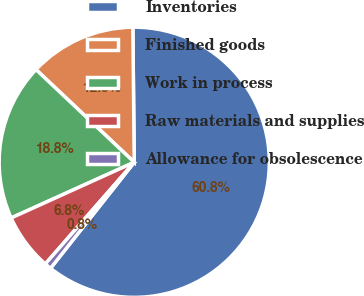Convert chart. <chart><loc_0><loc_0><loc_500><loc_500><pie_chart><fcel>Inventories<fcel>Finished goods<fcel>Work in process<fcel>Raw materials and supplies<fcel>Allowance for obsolescence<nl><fcel>60.8%<fcel>12.8%<fcel>18.8%<fcel>6.8%<fcel>0.8%<nl></chart> 